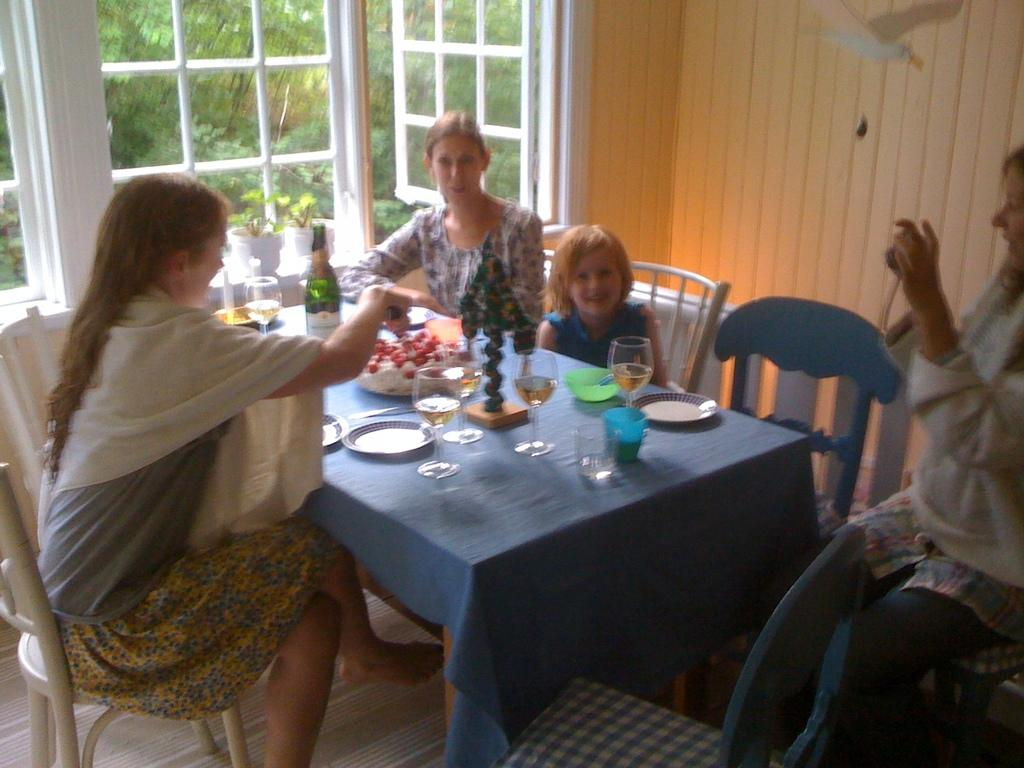What can be seen in the image that allows light and air to enter the room? There is a window in the image. What type of natural scenery can be seen through the window? There are trees visible in the image. What type of furniture is present in the room? There are chairs and tables in the image. What are the people sitting on in the image? There are people sitting on the chairs. What items can be seen on the table in the image? There are glasses, plates, and bottles on the table. What activity is the brother doing with the bag in the image? There is no brother or bag present in the image. What type of activity are the people engaged in while sitting on the chairs? The provided facts do not mention any specific activity that the people are engaged in while sitting on the chairs. 